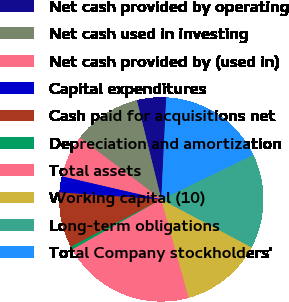<chart> <loc_0><loc_0><loc_500><loc_500><pie_chart><fcel>Net cash provided by operating<fcel>Net cash used in investing<fcel>Net cash provided by (used in)<fcel>Capital expenditures<fcel>Cash paid for acquisitions net<fcel>Depreciation and amortization<fcel>Total assets<fcel>Working capital (10)<fcel>Long-term obligations<fcel>Total Company stockholders'<nl><fcel>4.62%<fcel>10.83%<fcel>6.69%<fcel>2.55%<fcel>8.76%<fcel>0.48%<fcel>21.17%<fcel>12.9%<fcel>14.96%<fcel>17.03%<nl></chart> 